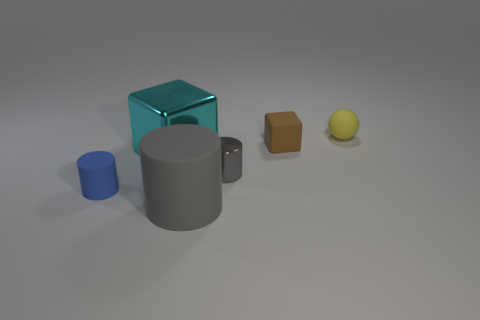Subtract all tiny cylinders. How many cylinders are left? 1 Add 4 metallic cylinders. How many objects exist? 10 Subtract all spheres. How many objects are left? 5 Add 6 big things. How many big things exist? 8 Subtract 0 gray blocks. How many objects are left? 6 Subtract all large green metal things. Subtract all big things. How many objects are left? 4 Add 1 matte blocks. How many matte blocks are left? 2 